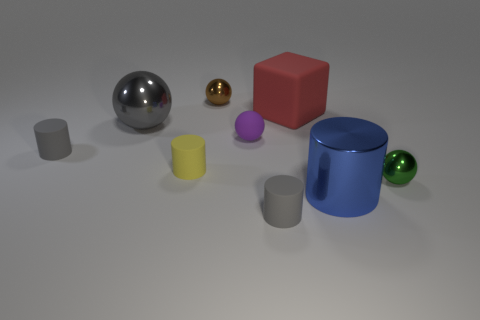Subtract all purple spheres. How many spheres are left? 3 Add 1 small yellow matte cylinders. How many objects exist? 10 Subtract all brown spheres. How many spheres are left? 3 Subtract all cylinders. How many objects are left? 5 Subtract 3 balls. How many balls are left? 1 Subtract all brown cubes. How many green spheres are left? 1 Subtract all cyan spheres. Subtract all yellow cylinders. How many objects are left? 8 Add 4 gray things. How many gray things are left? 7 Add 7 purple things. How many purple things exist? 8 Subtract 1 gray spheres. How many objects are left? 8 